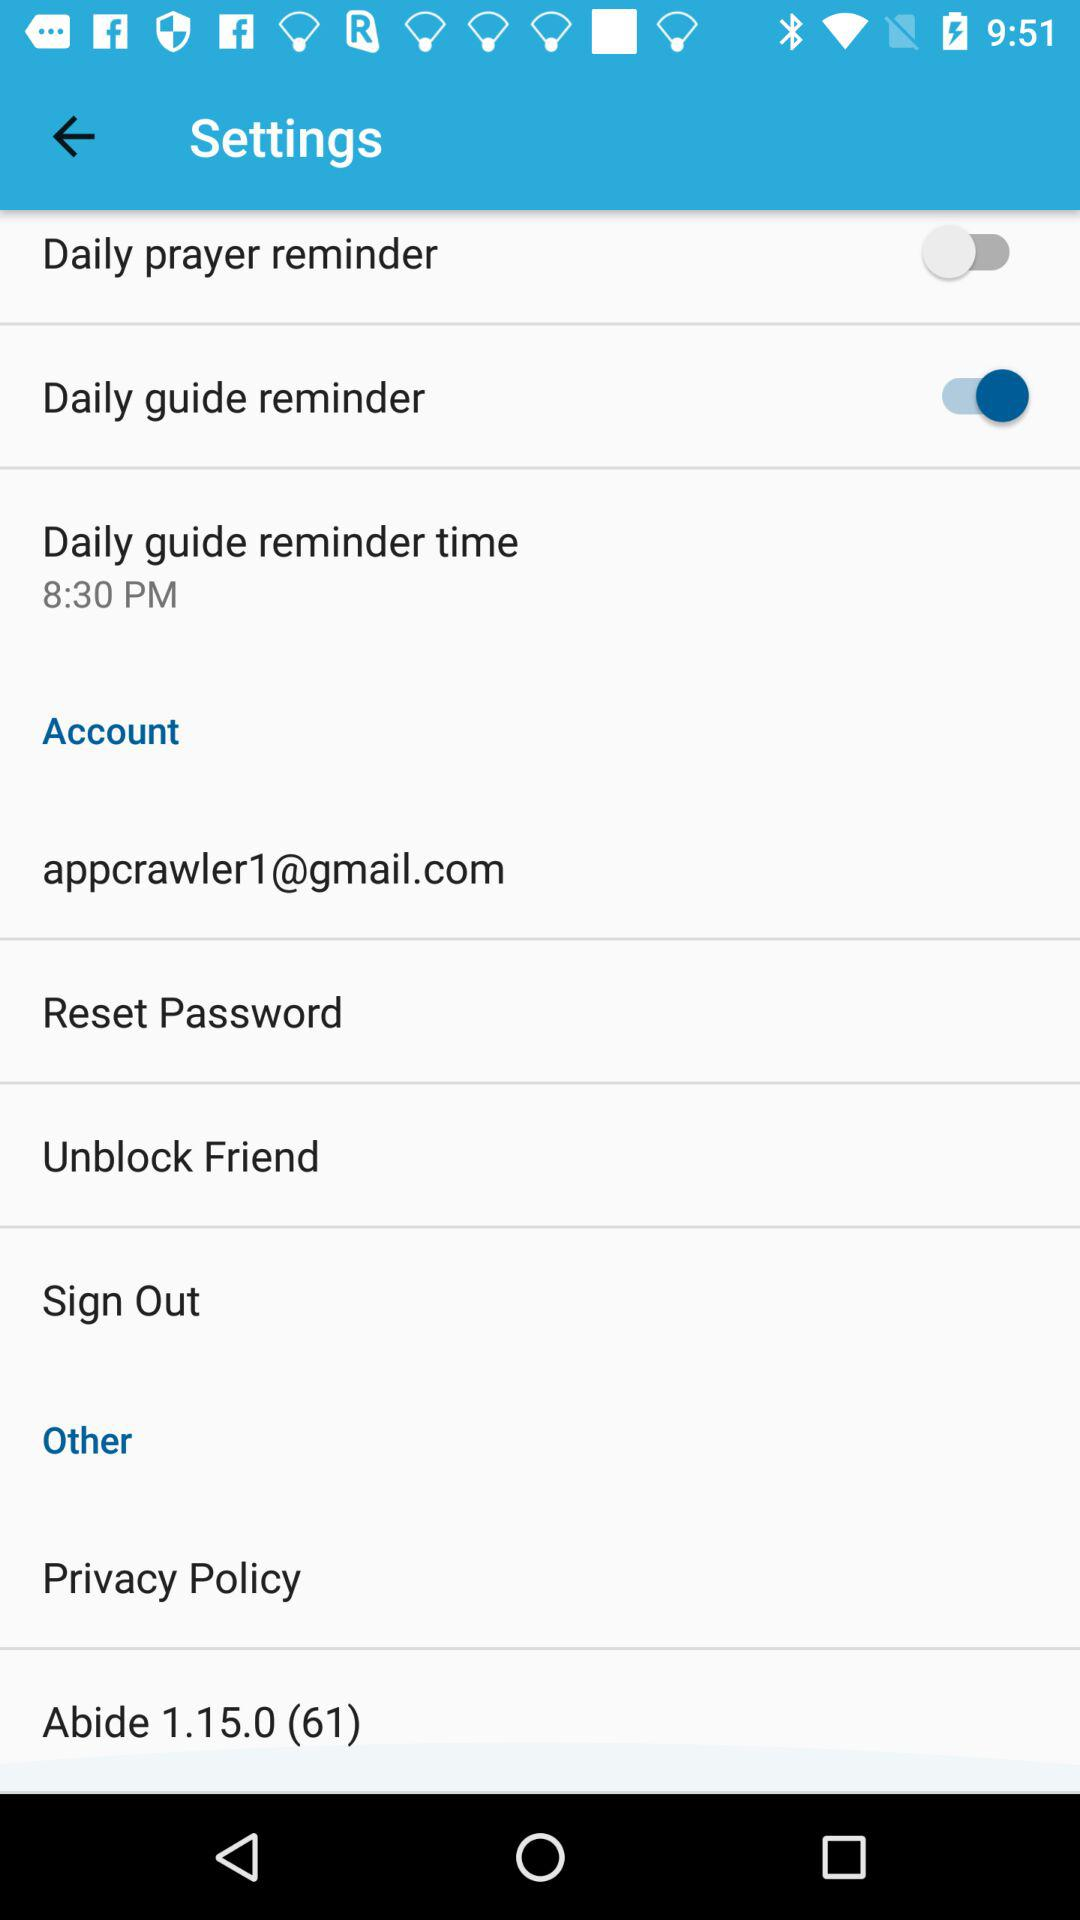What is the status of the "Daily guide reminder"? The status is "on". 